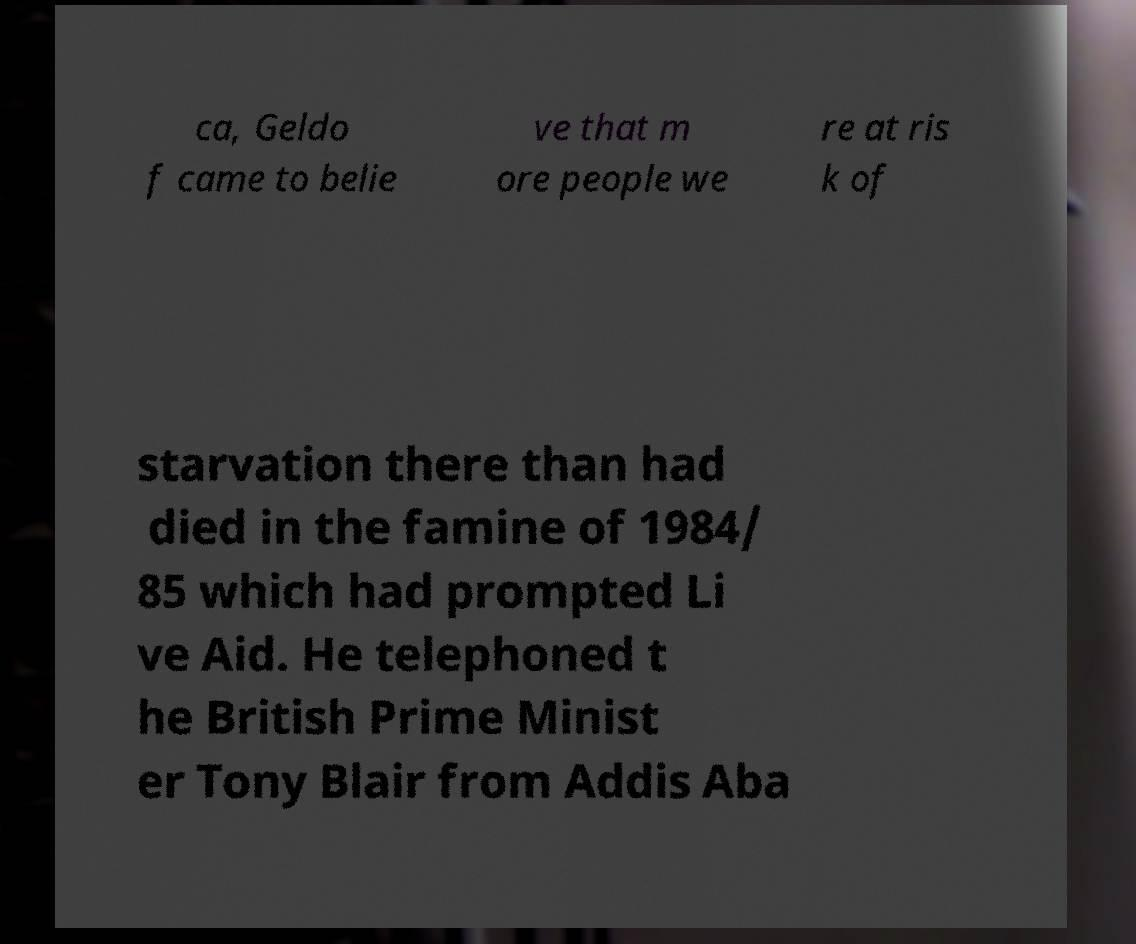Could you assist in decoding the text presented in this image and type it out clearly? ca, Geldo f came to belie ve that m ore people we re at ris k of starvation there than had died in the famine of 1984/ 85 which had prompted Li ve Aid. He telephoned t he British Prime Minist er Tony Blair from Addis Aba 